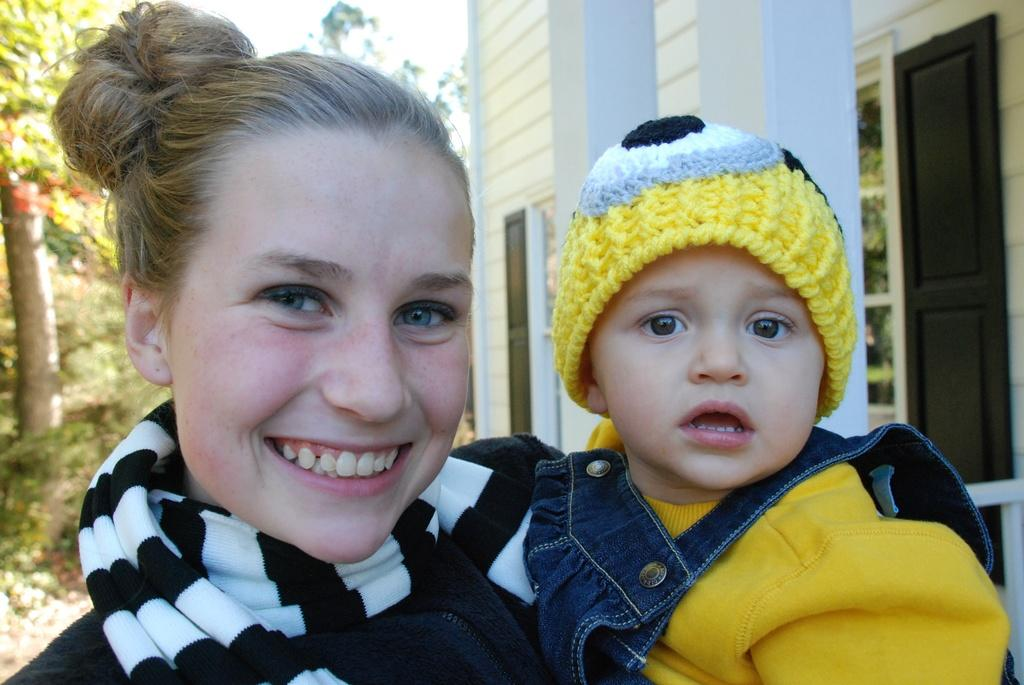Who is the main subject in the image? There is a woman in the image. What is the woman doing in the image? The woman is smiling and carrying a baby. What can be seen in the background of the image? There are trees and a house in the background of the image. What is the theory behind the moon's effect on the woman's breath in the image? There is no mention of the moon or breath in the image, so it is not possible to discuss any theories related to them. 